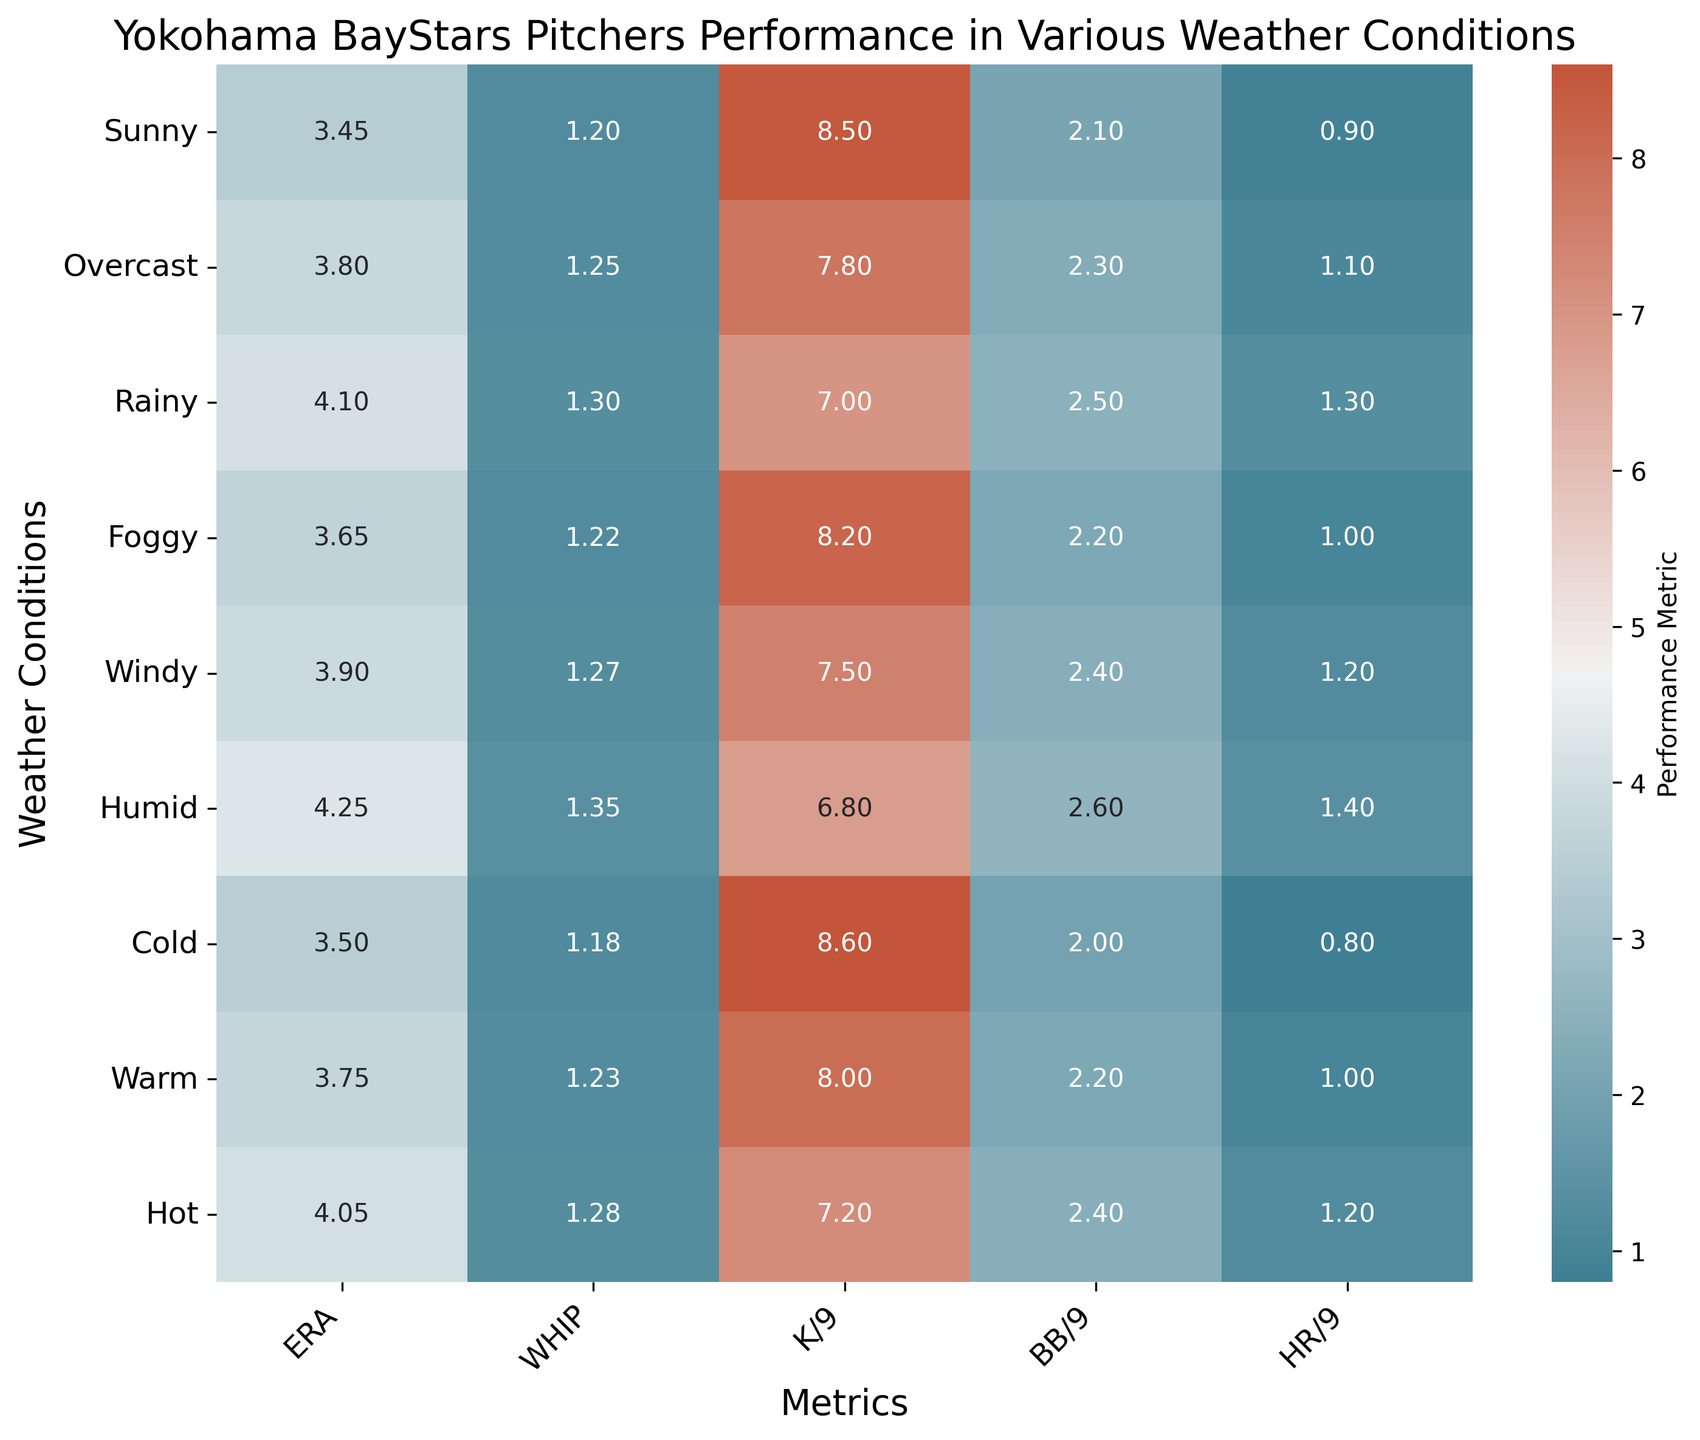Which weather condition exhibits the highest ERA? By examining the heatmap, we look for the weather condition corresponding to the highest value in the ERA column, which is marked by a specific darker color. In this case, Humid has the highest ERA of 4.25.
Answer: Humid How does the WHIP in Hot compare to Cold? We find the WHIP values for both Hot (1.28) and Cold (1.18) and observe that the Hot condition has a slightly higher WHIP than Cold.
Answer: Hot has a higher WHIP What's the difference in HR/9 between Sunny and Rainy conditions? By locating the HR/9 values for both Sunny (0.9) and Rainy (1.3), we calculate the difference: 1.3 - 0.9 = 0.4.
Answer: 0.4 Which conditions have an ERA below 3.70? By inspecting the ERA column and identifying values below 3.70, we see that these conditions are Sunny (3.45), Cold (3.50), and Foggy (3.65).
Answer: Sunny, Cold, Foggy What's the average WHIP across all weather conditions? We sum all WHIP values (1.20, 1.25, 1.30, 1.22, 1.27, 1.35, 1.18, 1.23, 1.28) and divide by the number of conditions (9). The calculation is (11.28 / 9) = 1.253.
Answer: 1.253 Compare the K/9 between Overcast and Warm; which is higher? Observing the K/9 values for Overcast (7.8) and Warm (8.0), Warm has a higher K/9.
Answer: Warm Which weather condition shows the lowest BB/9? By finding the minimum value in the BB/9 column, Sunny has the lowest BB/9 of 2.1.
Answer: Sunny If we combine ERA and HR/9 for Foggy, what is the result? Adding the ERA (3.65) and HR/9 (1.0) for Foggy gives us 3.65 + 1.0 = 4.65.
Answer: 4.65 Is the WHIP higher in Windy or Humid conditions? Comparing WHIP values for Windy (1.27) and Humid (1.35), Humid has a higher WHIP.
Answer: Humid What's the sum of BB/9 values for all conditions? Adding up all BB/9 values (2.1, 2.3, 2.5, 2.2, 2.4, 2.6, 2.0, 2.2, 2.4), the total is 21.7.
Answer: 21.7 